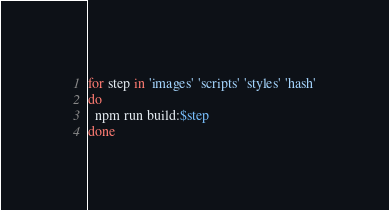Convert code to text. <code><loc_0><loc_0><loc_500><loc_500><_Bash_>for step in 'images' 'scripts' 'styles' 'hash'
do
  npm run build:$step
done
</code> 